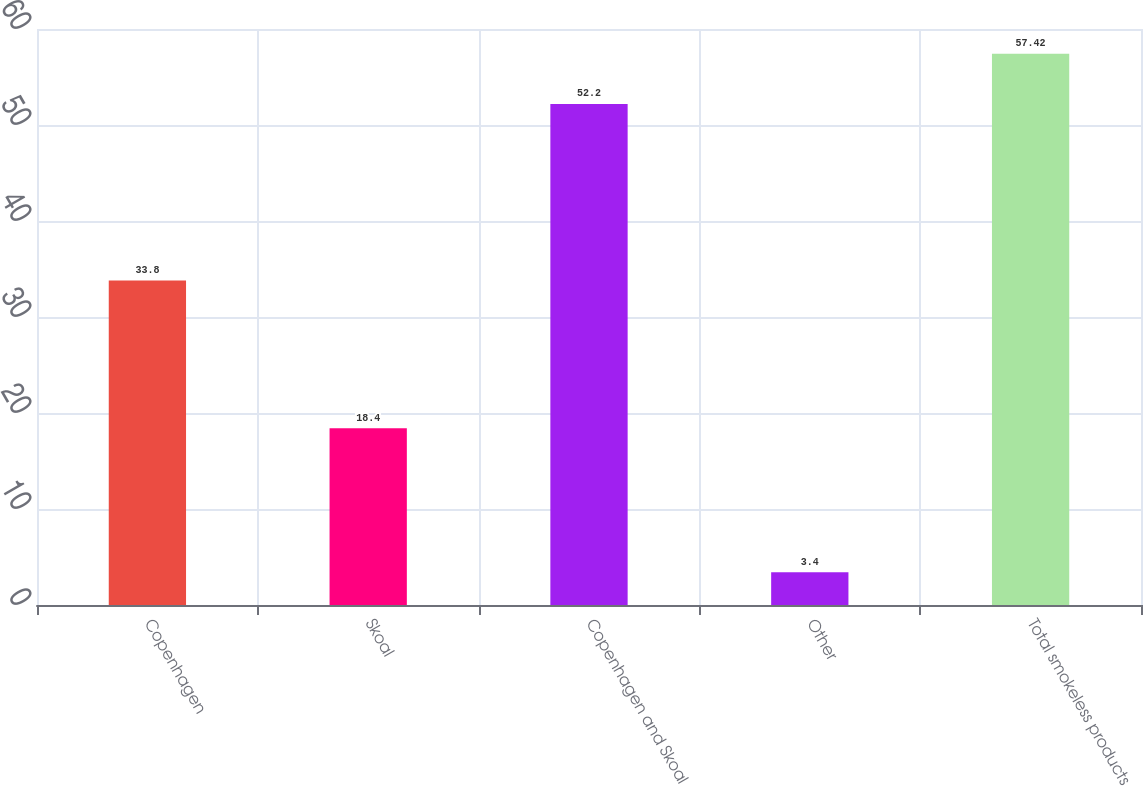Convert chart to OTSL. <chart><loc_0><loc_0><loc_500><loc_500><bar_chart><fcel>Copenhagen<fcel>Skoal<fcel>Copenhagen and Skoal<fcel>Other<fcel>Total smokeless products<nl><fcel>33.8<fcel>18.4<fcel>52.2<fcel>3.4<fcel>57.42<nl></chart> 